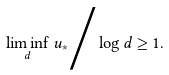Convert formula to latex. <formula><loc_0><loc_0><loc_500><loc_500>\liminf _ { d } u _ { * } \Big / \log d \geq 1 .</formula> 